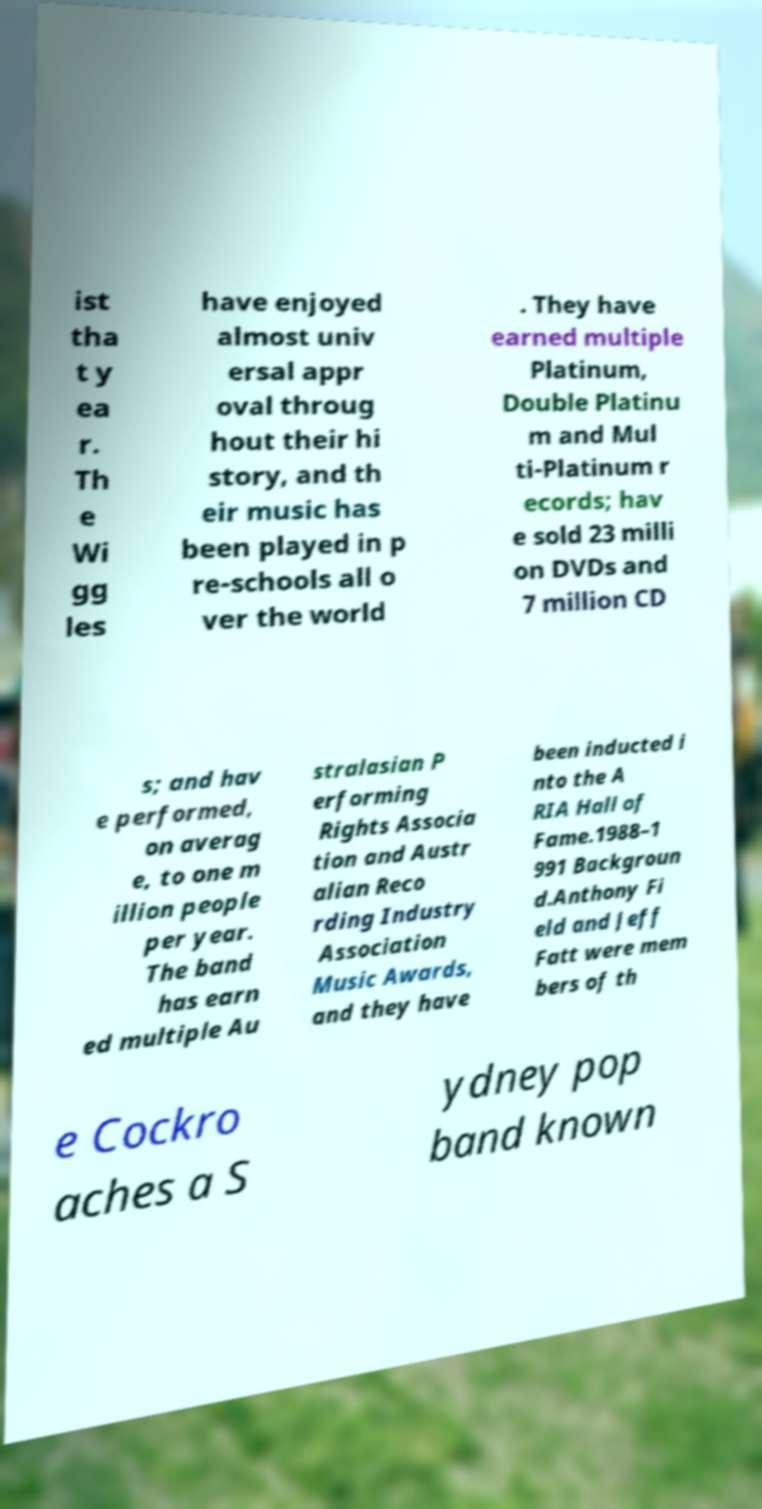I need the written content from this picture converted into text. Can you do that? ist tha t y ea r. Th e Wi gg les have enjoyed almost univ ersal appr oval throug hout their hi story, and th eir music has been played in p re-schools all o ver the world . They have earned multiple Platinum, Double Platinu m and Mul ti-Platinum r ecords; hav e sold 23 milli on DVDs and 7 million CD s; and hav e performed, on averag e, to one m illion people per year. The band has earn ed multiple Au stralasian P erforming Rights Associa tion and Austr alian Reco rding Industry Association Music Awards, and they have been inducted i nto the A RIA Hall of Fame.1988–1 991 Backgroun d.Anthony Fi eld and Jeff Fatt were mem bers of th e Cockro aches a S ydney pop band known 